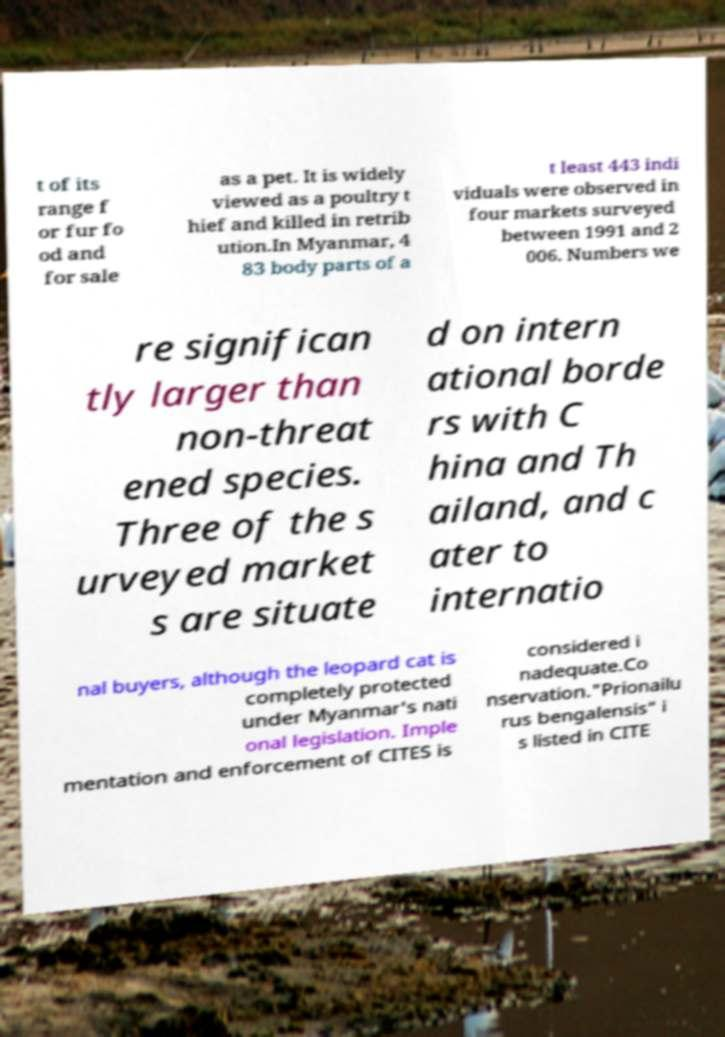Please identify and transcribe the text found in this image. t of its range f or fur fo od and for sale as a pet. It is widely viewed as a poultry t hief and killed in retrib ution.In Myanmar, 4 83 body parts of a t least 443 indi viduals were observed in four markets surveyed between 1991 and 2 006. Numbers we re significan tly larger than non-threat ened species. Three of the s urveyed market s are situate d on intern ational borde rs with C hina and Th ailand, and c ater to internatio nal buyers, although the leopard cat is completely protected under Myanmar's nati onal legislation. Imple mentation and enforcement of CITES is considered i nadequate.Co nservation."Prionailu rus bengalensis" i s listed in CITE 